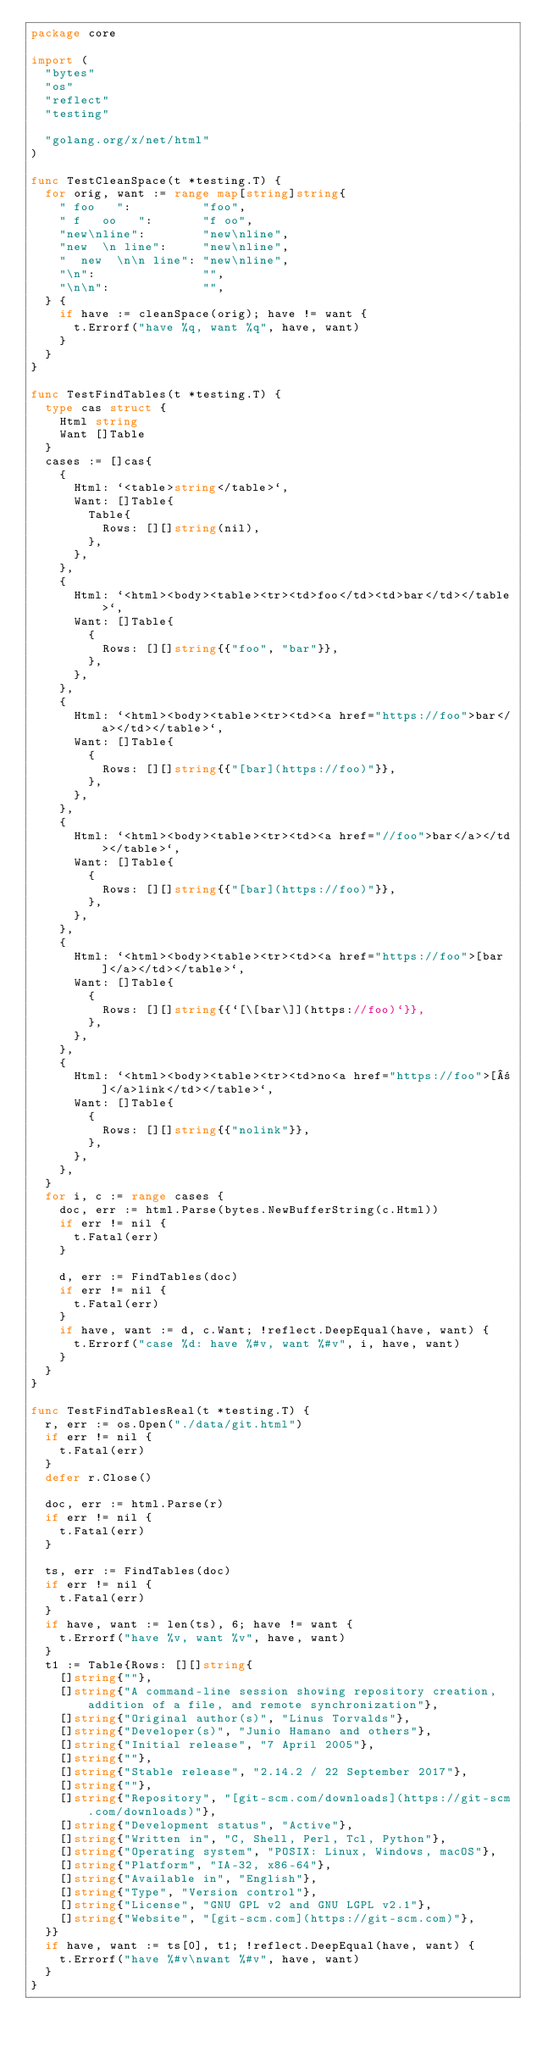<code> <loc_0><loc_0><loc_500><loc_500><_Go_>package core

import (
	"bytes"
	"os"
	"reflect"
	"testing"

	"golang.org/x/net/html"
)

func TestCleanSpace(t *testing.T) {
	for orig, want := range map[string]string{
		" foo   ":          "foo",
		" f   oo   ":       "f oo",
		"new\nline":        "new\nline",
		"new  \n line":     "new\nline",
		"  new  \n\n line": "new\nline",
		"\n":               "",
		"\n\n":             "",
	} {
		if have := cleanSpace(orig); have != want {
			t.Errorf("have %q, want %q", have, want)
		}
	}
}

func TestFindTables(t *testing.T) {
	type cas struct {
		Html string
		Want []Table
	}
	cases := []cas{
		{
			Html: `<table>string</table>`,
			Want: []Table{
				Table{
					Rows: [][]string(nil),
				},
			},
		},
		{
			Html: `<html><body><table><tr><td>foo</td><td>bar</td></table>`,
			Want: []Table{
				{
					Rows: [][]string{{"foo", "bar"}},
				},
			},
		},
		{
			Html: `<html><body><table><tr><td><a href="https://foo">bar</a></td></table>`,
			Want: []Table{
				{
					Rows: [][]string{{"[bar](https://foo)"}},
				},
			},
		},
		{
			Html: `<html><body><table><tr><td><a href="//foo">bar</a></td></table>`,
			Want: []Table{
				{
					Rows: [][]string{{"[bar](https://foo)"}},
				},
			},
		},
		{
			Html: `<html><body><table><tr><td><a href="https://foo">[bar]</a></td></table>`,
			Want: []Table{
				{
					Rows: [][]string{{`[\[bar\]](https://foo)`}},
				},
			},
		},
		{
			Html: `<html><body><table><tr><td>no<a href="https://foo">[±]</a>link</td></table>`,
			Want: []Table{
				{
					Rows: [][]string{{"nolink"}},
				},
			},
		},
	}
	for i, c := range cases {
		doc, err := html.Parse(bytes.NewBufferString(c.Html))
		if err != nil {
			t.Fatal(err)
		}

		d, err := FindTables(doc)
		if err != nil {
			t.Fatal(err)
		}
		if have, want := d, c.Want; !reflect.DeepEqual(have, want) {
			t.Errorf("case %d: have %#v, want %#v", i, have, want)
		}
	}
}

func TestFindTablesReal(t *testing.T) {
	r, err := os.Open("./data/git.html")
	if err != nil {
		t.Fatal(err)
	}
	defer r.Close()

	doc, err := html.Parse(r)
	if err != nil {
		t.Fatal(err)
	}

	ts, err := FindTables(doc)
	if err != nil {
		t.Fatal(err)
	}
	if have, want := len(ts), 6; have != want {
		t.Errorf("have %v, want %v", have, want)
	}
	t1 := Table{Rows: [][]string{
		[]string{""},
		[]string{"A command-line session showing repository creation, addition of a file, and remote synchronization"},
		[]string{"Original author(s)", "Linus Torvalds"},
		[]string{"Developer(s)", "Junio Hamano and others"},
		[]string{"Initial release", "7 April 2005"},
		[]string{""},
		[]string{"Stable release", "2.14.2 / 22 September 2017"},
		[]string{""},
		[]string{"Repository", "[git-scm.com/downloads](https://git-scm.com/downloads)"},
		[]string{"Development status", "Active"},
		[]string{"Written in", "C, Shell, Perl, Tcl, Python"},
		[]string{"Operating system", "POSIX: Linux, Windows, macOS"},
		[]string{"Platform", "IA-32, x86-64"},
		[]string{"Available in", "English"},
		[]string{"Type", "Version control"},
		[]string{"License", "GNU GPL v2 and GNU LGPL v2.1"},
		[]string{"Website", "[git-scm.com](https://git-scm.com)"},
	}}
	if have, want := ts[0], t1; !reflect.DeepEqual(have, want) {
		t.Errorf("have %#v\nwant %#v", have, want)
	}
}
</code> 